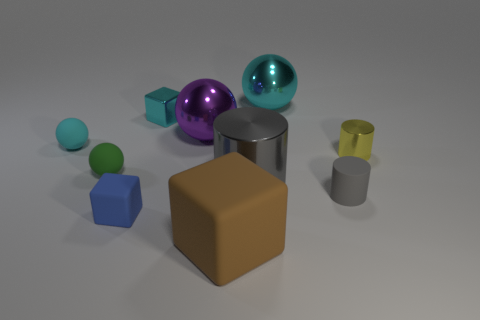Subtract all balls. How many objects are left? 6 Add 1 small gray cylinders. How many small gray cylinders are left? 2 Add 6 big cyan metallic objects. How many big cyan metallic objects exist? 7 Subtract 0 purple blocks. How many objects are left? 10 Subtract all big cyan metal spheres. Subtract all blue rubber cubes. How many objects are left? 8 